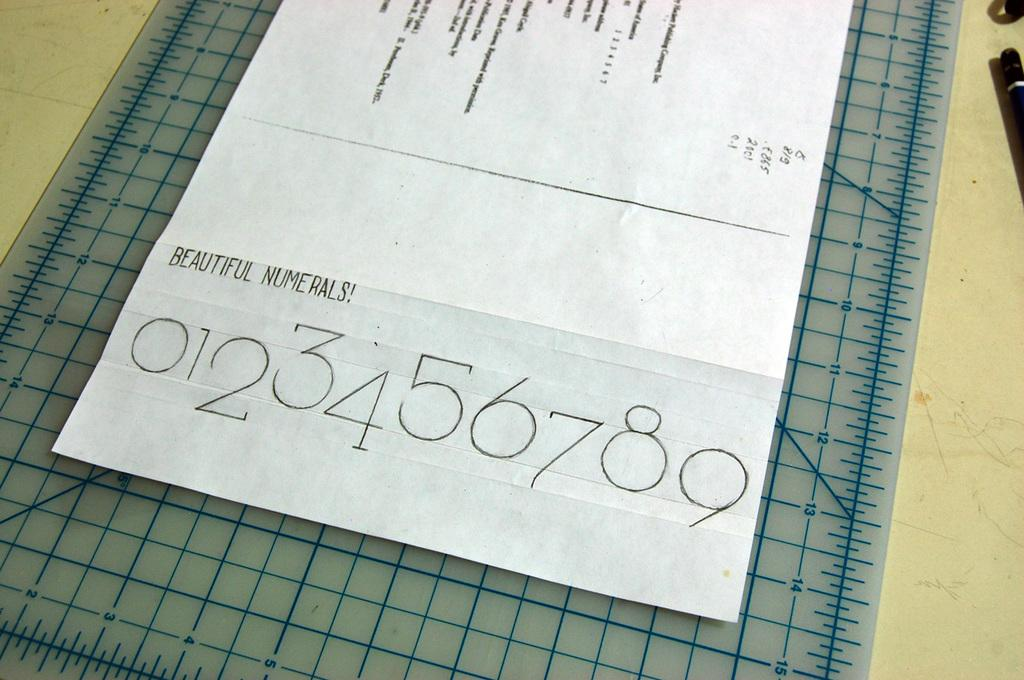Provide a one-sentence caption for the provided image. a paper on top of a counter that says 'beautiful numerals!' on it. 